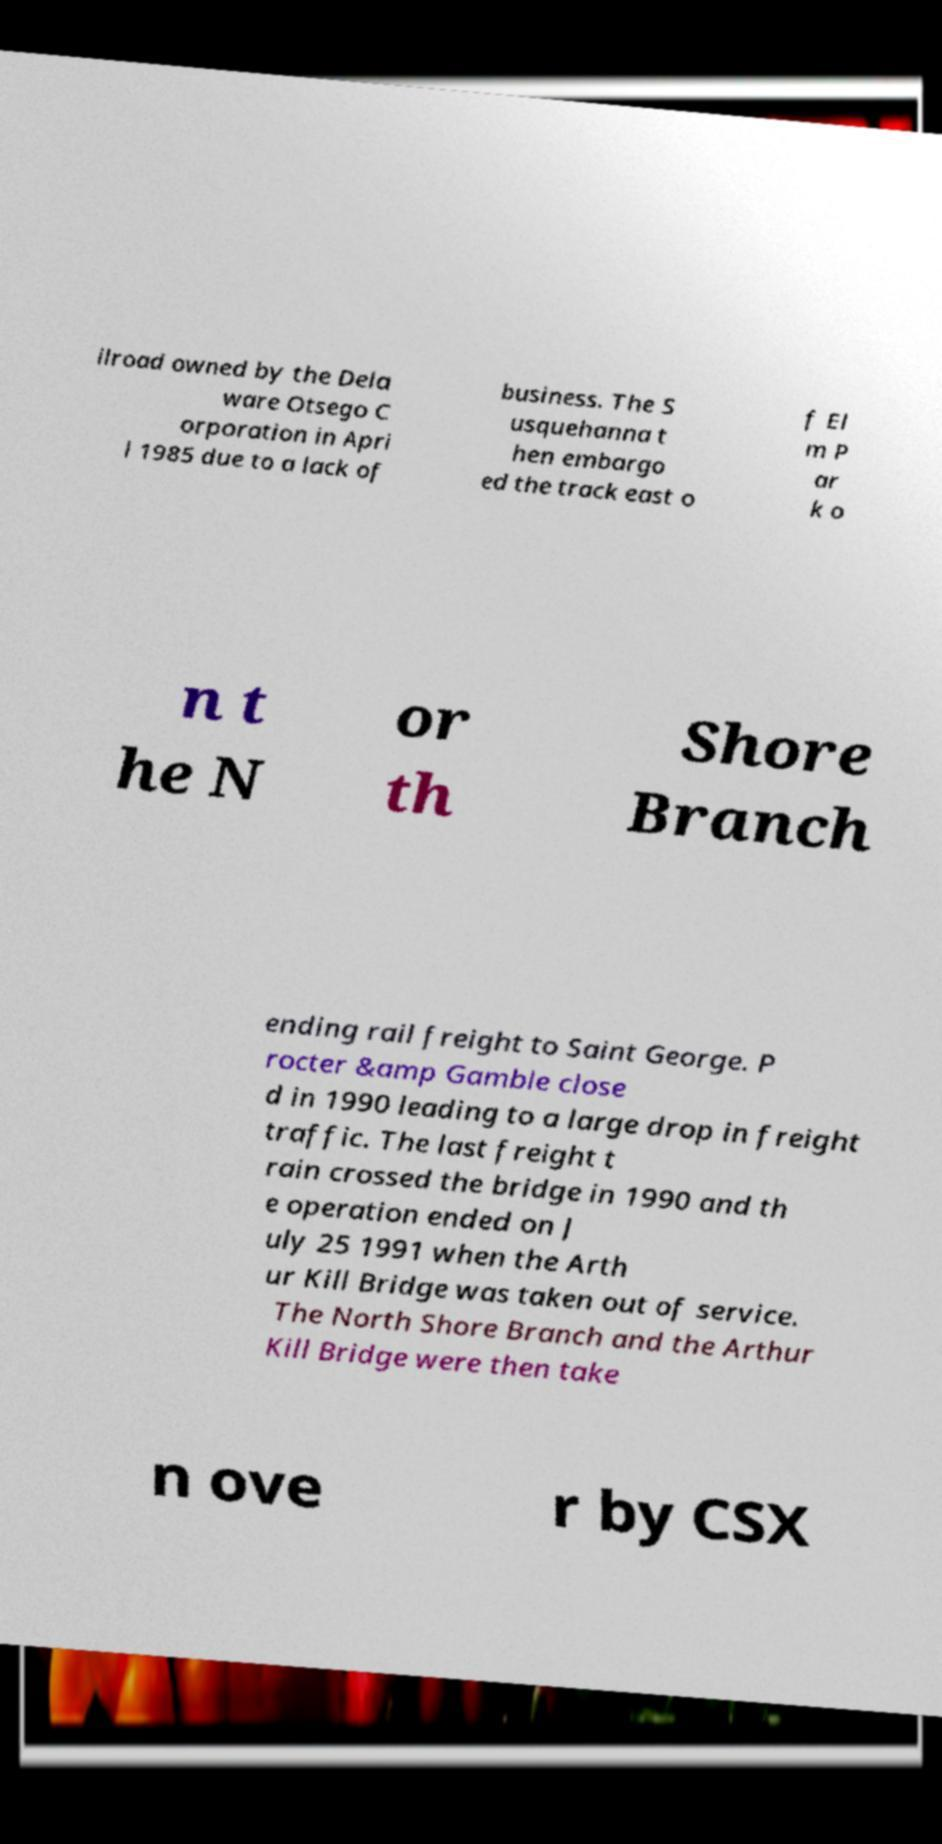Please read and relay the text visible in this image. What does it say? ilroad owned by the Dela ware Otsego C orporation in Apri l 1985 due to a lack of business. The S usquehanna t hen embargo ed the track east o f El m P ar k o n t he N or th Shore Branch ending rail freight to Saint George. P rocter &amp Gamble close d in 1990 leading to a large drop in freight traffic. The last freight t rain crossed the bridge in 1990 and th e operation ended on J uly 25 1991 when the Arth ur Kill Bridge was taken out of service. The North Shore Branch and the Arthur Kill Bridge were then take n ove r by CSX 